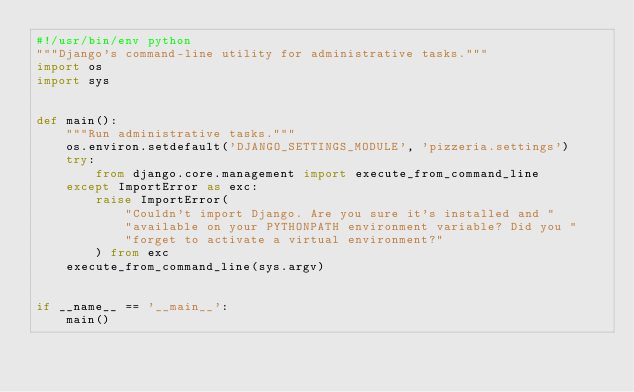Convert code to text. <code><loc_0><loc_0><loc_500><loc_500><_Python_>#!/usr/bin/env python
"""Django's command-line utility for administrative tasks."""
import os
import sys


def main():
    """Run administrative tasks."""
    os.environ.setdefault('DJANGO_SETTINGS_MODULE', 'pizzeria.settings')
    try:
        from django.core.management import execute_from_command_line
    except ImportError as exc:
        raise ImportError(
            "Couldn't import Django. Are you sure it's installed and "
            "available on your PYTHONPATH environment variable? Did you "
            "forget to activate a virtual environment?"
        ) from exc
    execute_from_command_line(sys.argv)


if __name__ == '__main__':
    main()
</code> 